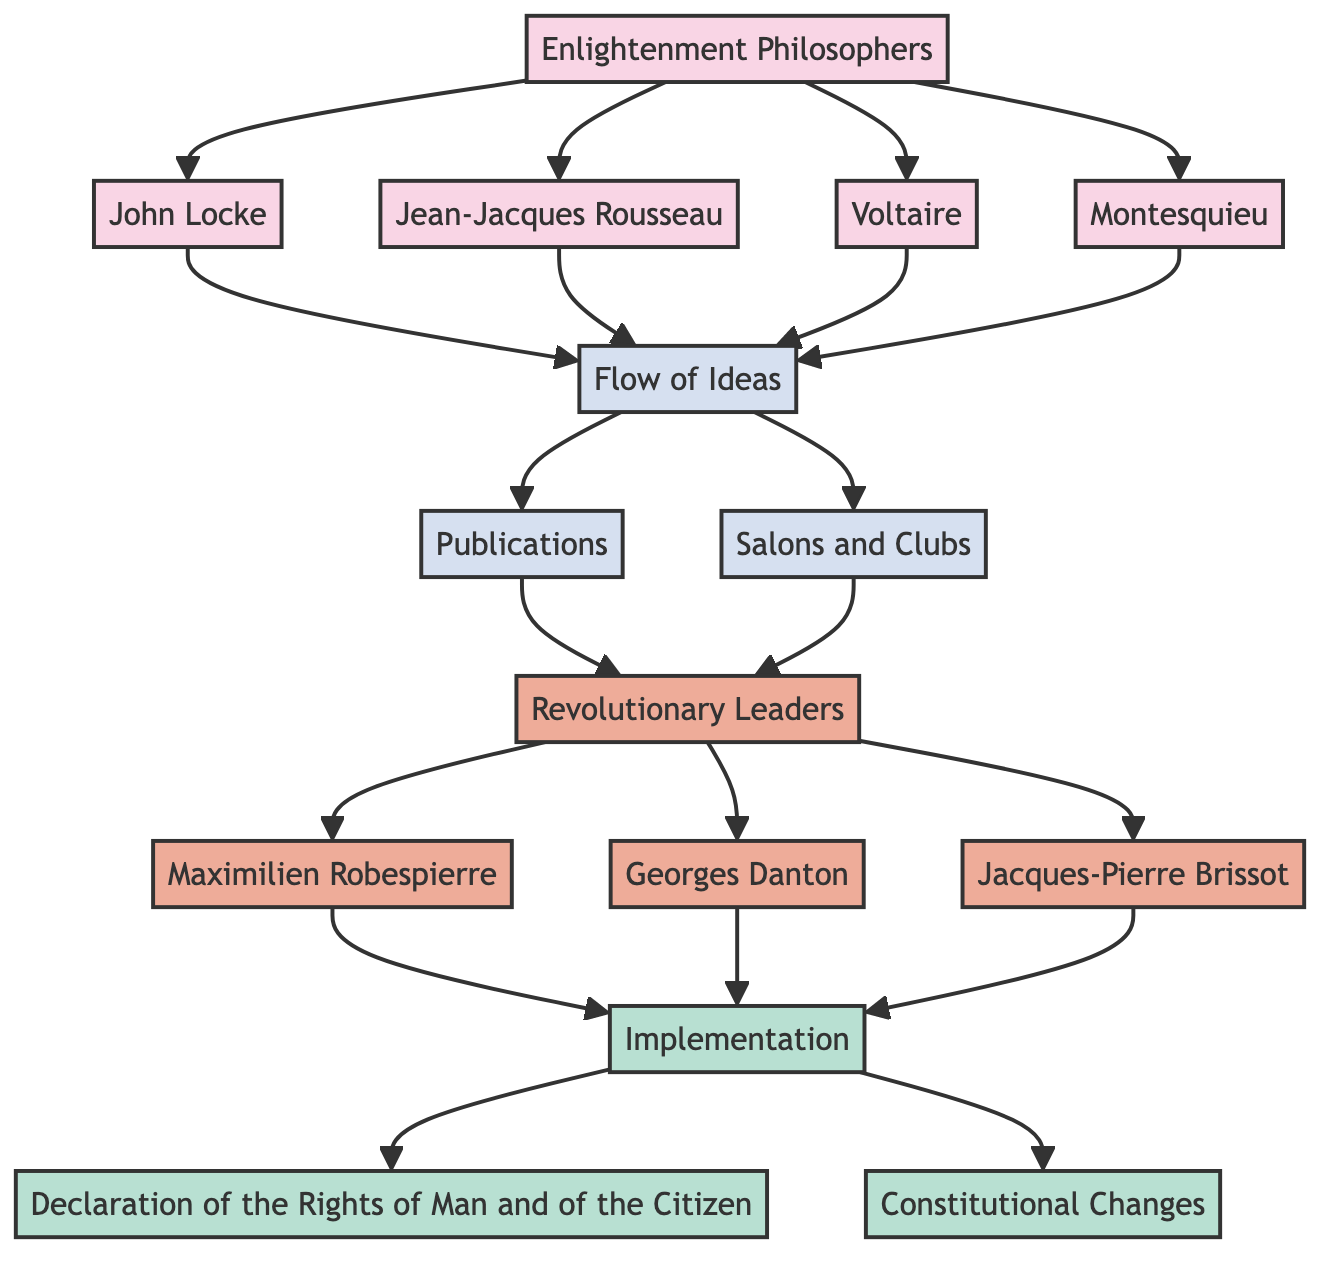What is the main title of the flow chart? The title is clearly labeled at the top of the diagram, indicating the overall theme of the chart.
Answer: The Influence of Enlightenment Ideas on Revolutionary Leaders: Tracing the Flow of Philosophical Concepts How many Enlightenment philosophers are mentioned? Each philosopher is represented as a distinct node, and by counting these, we find four in total: John Locke, Jean-Jacques Rousseau, Voltaire, and Montesquieu.
Answer: 4 Which philosopher advocated for the social contract? Among the philosophers listed, Jean-Jacques Rousseau is specifically noted for his advocacy of the social contract.
Answer: Jean-Jacques Rousseau What is the relationship between Revolutionary Leaders and Flow of Ideas? The arrow from Revolutionary Leaders to Flow of Ideas indicates that there is a directional influence where the Revolutionary Leaders draw upon the Flow of Ideas.
Answer: Influenced by What documents resulted from the Implementation of Enlightenment ideas? The flow chart indicates that the Implementation leads to two significant outputs: the Declaration of the Rights of Man and of the Citizen and Constitutional Changes.
Answer: Declaration of the Rights of Man and of the Citizen, Constitutional Changes Which leader is connected to Rousseau's ideas? The diagram indicates that Maximilien Robespierre is specifically associated with Rousseau's ideas, highlighting his support for this philosopher.
Answer: Maximilien Robespierre What are the two main sources of the Flow of Ideas? Reviewing the flow from the Flow of Ideas, we see there are two sources identified: Publications and Salons and Clubs.
Answer: Publications, Salons and Clubs How many Revolutionary Leaders are depicted in the chart? Counting the nodes connected to Revolutionary Leaders reveals a total of three prominent figures: Maximilien Robespierre, Georges Danton, and Jacques-Pierre Brissot.
Answer: 3 What does the flow chart illustrate about the Enlightenment philosophers? The diagram systematically illustrates the influence of Enlightenment philosophers on the subsequent development of revolutionary ideas and leadership.
Answer: Influence on Revolutionary Leaders 